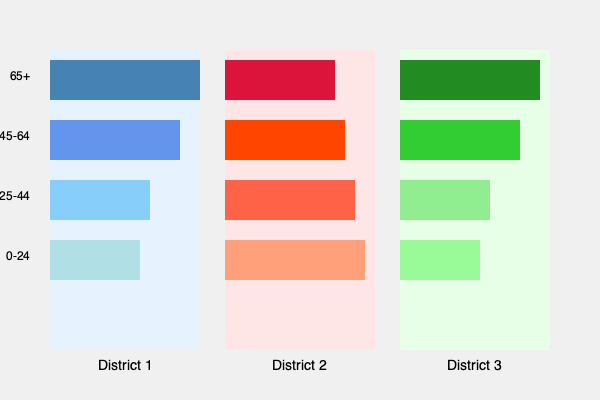Based on the population pyramids shown for Nebraska's three congressional districts, which district appears to have the highest concentration of young adults (25-44 age group) and what implications might this have for political engagement and representation? To answer this question, we need to analyze the population pyramids for each district:

1. Examine the 25-44 age group across all districts:
   - District 1: Moderately sized bar
   - District 2: Largest bar for this age group
   - District 3: Relatively small bar

2. Compare the size of the 25-44 age group to other age groups within each district:
   - District 1: 25-44 group is smaller than 45-64 and 65+ groups
   - District 2: 25-44 group is larger than 45-64 and 65+ groups
   - District 3: 25-44 group is smaller than all other age groups

3. Conclude that District 2 has the highest concentration of young adults (25-44 age group).

4. Consider the implications for political engagement and representation:
   a) Higher voter turnout: Young adults are often more politically active.
   b) Different policy priorities: Focus on issues like job creation, housing affordability, and education.
   c) Potential for progressive leanings: Younger voters tend to be more liberal on social issues.
   d) Increased use of digital campaigning: Young adults are more likely to engage with politics online.
   e) Representation: Candidates may skew younger to appeal to this demographic.

5. Contrast with other districts:
   - District 1 and 3 have older populations, which may lead to different political priorities and campaigning strategies.
Answer: District 2; implications include higher youth voter turnout, focus on issues relevant to young adults, potential progressive leanings, increased digital campaigning, and younger candidates. 